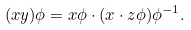Convert formula to latex. <formula><loc_0><loc_0><loc_500><loc_500>( x y ) \phi = x \phi \cdot ( x \cdot z \phi ) \phi ^ { - 1 } .</formula> 